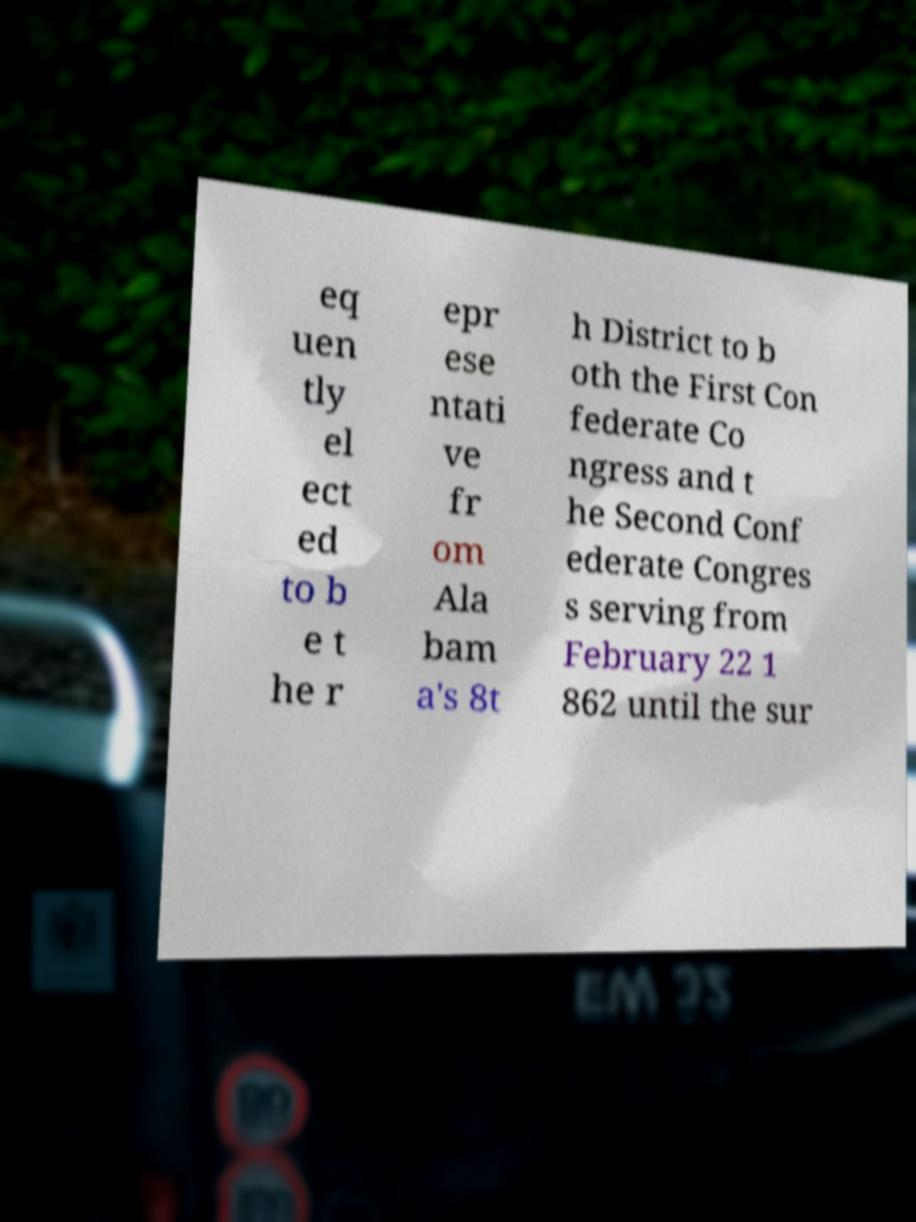For documentation purposes, I need the text within this image transcribed. Could you provide that? eq uen tly el ect ed to b e t he r epr ese ntati ve fr om Ala bam a's 8t h District to b oth the First Con federate Co ngress and t he Second Conf ederate Congres s serving from February 22 1 862 until the sur 